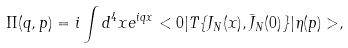Convert formula to latex. <formula><loc_0><loc_0><loc_500><loc_500>\Pi ( q , p ) = i \int d ^ { 4 } x e ^ { i q x } < 0 | T \{ J _ { N } ( x ) , \bar { J } _ { N } ( 0 ) \} | \eta ( p ) > ,</formula> 